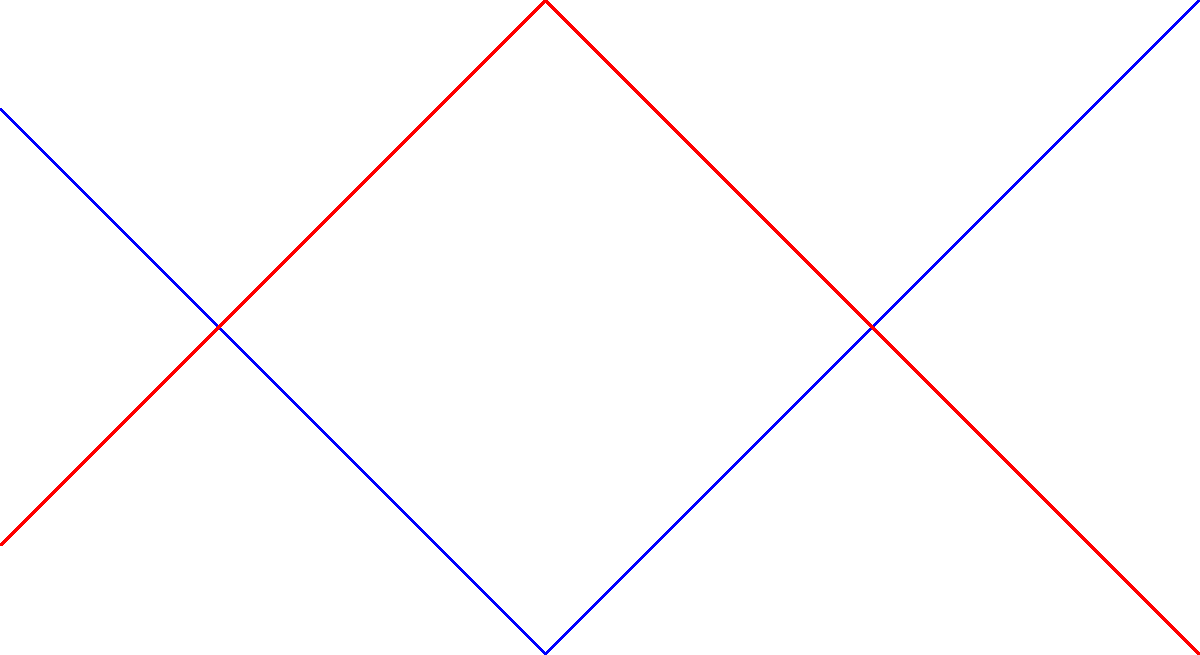As you blend teas inspired by the rhythms of celestial bodies, you notice a pattern in the visibility of certain constellations. Using the graph, which depicts the visibility of a particular constellation throughout the year in both hemispheres, during which month is this constellation most visible in the Southern Hemisphere, aligning perfectly with your "Cosmic Jazz Oolong" blend? To answer this question, let's analyze the graph step-by-step:

1. The graph shows two lines: blue for the Northern Hemisphere and red for the Southern Hemisphere.
2. The x-axis represents months, while the y-axis represents visibility (higher values indicate better visibility).
3. We need to focus on the red line, which represents the Southern Hemisphere.
4. Tracing the red line, we can see it reaches its peak (highest point) in June.
5. This peak indicates the month when the constellation is most visible in the Southern Hemisphere.
6. The visibility in June aligns with the winter season in the Southern Hemisphere, when nights are longer and skies are often clearer.
7. This timing would be perfect for a "Cosmic Jazz Oolong" blend, as it coincides with the best stargazing conditions in the Southern Hemisphere.

Therefore, the constellation is most visible in the Southern Hemisphere in June, making it the ideal time to enjoy your "Cosmic Jazz Oolong" blend while stargazing.
Answer: June 